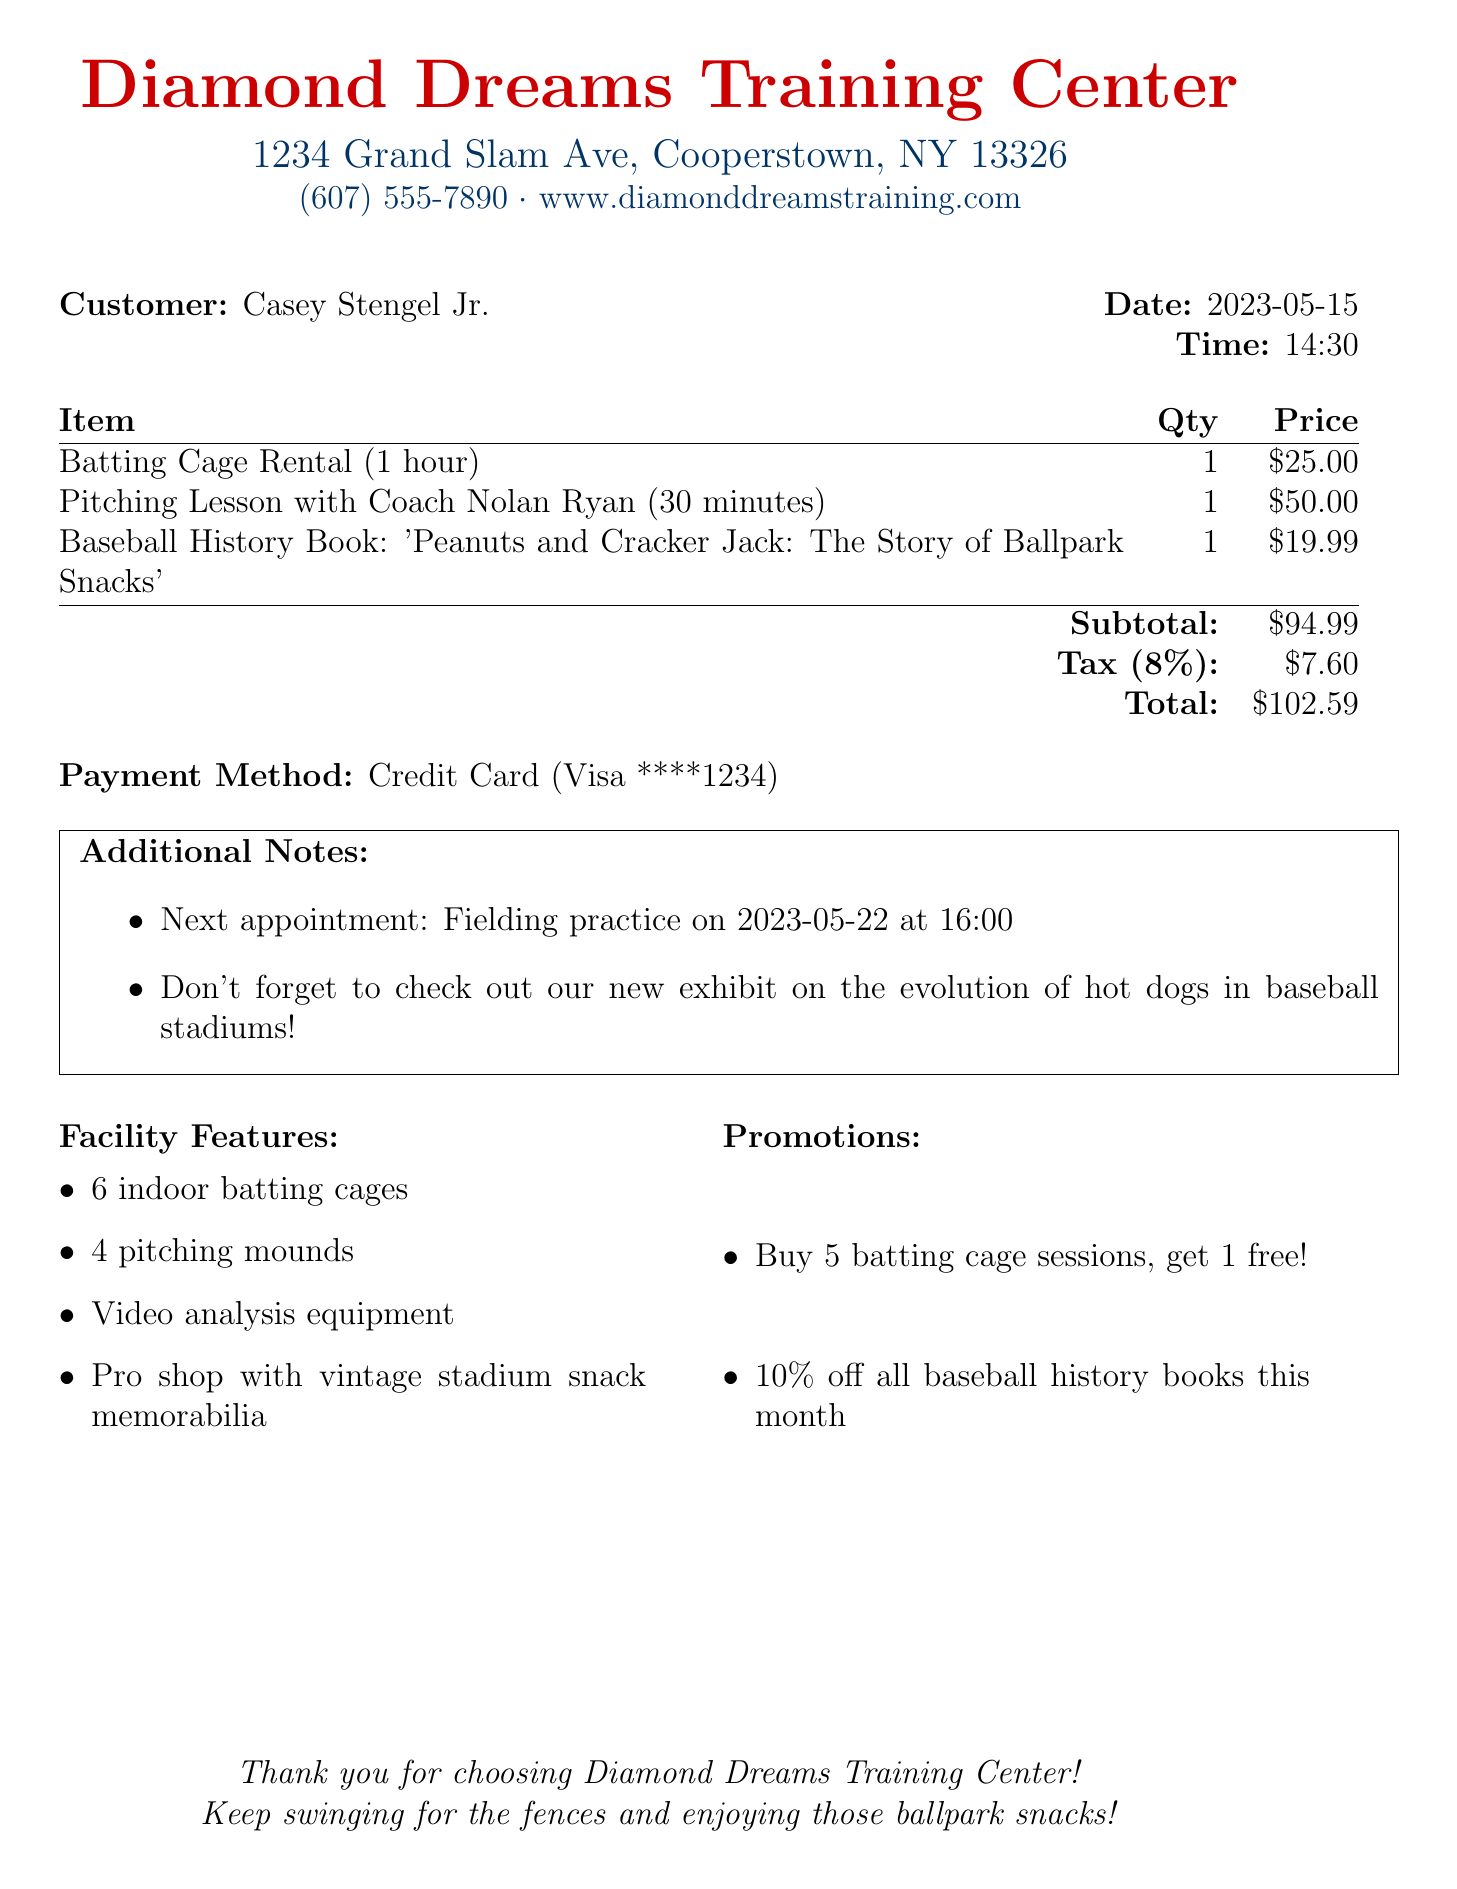What is the name of the training center? The name is stated at the top of the document under the business name section.
Answer: Diamond Dreams Training Center What is the address of the training center? The address is provided in the header of the document.
Answer: 1234 Grand Slam Ave, Cooperstown, NY 13326 What is the total amount charged? The total is listed in the summary section of the receipt.
Answer: 102.59 Who provided the pitching lesson? The name of the coach is mentioned in the item description for the pitching lesson.
Answer: Coach Nolan Ryan What is the date of the next appointment? The date is included in the additional notes section of the receipt.
Answer: 2023-05-22 How many indoor batting cages are available at the facility? The number of batting cages is mentioned in the facility features section.
Answer: 6 What is one of the promotions currently being offered? The promotions are listed in their own section with different offers.
Answer: Buy 5 batting cage sessions, get 1 free! What payment method was used for this transaction? The payment method is noted in the summary section of the receipt.
Answer: Credit Card (Visa ****1234) What is included in the baseball history book title purchased? The title of the book is mentioned in the items section of the receipt.
Answer: Peanuts and Cracker Jack: The Story of Ballpark Snacks 